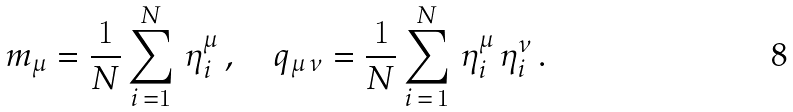Convert formula to latex. <formula><loc_0><loc_0><loc_500><loc_500>m _ { \mu } = \frac { 1 } { N } \sum _ { i \, = 1 } ^ { N } \, \eta _ { i } ^ { \mu } \, , \quad q _ { \mu \, \nu } = \frac { 1 } { N } \sum _ { i \, = \, 1 } ^ { N } \, \eta _ { i } ^ { \mu } \, \eta _ { i } ^ { \nu } \, .</formula> 